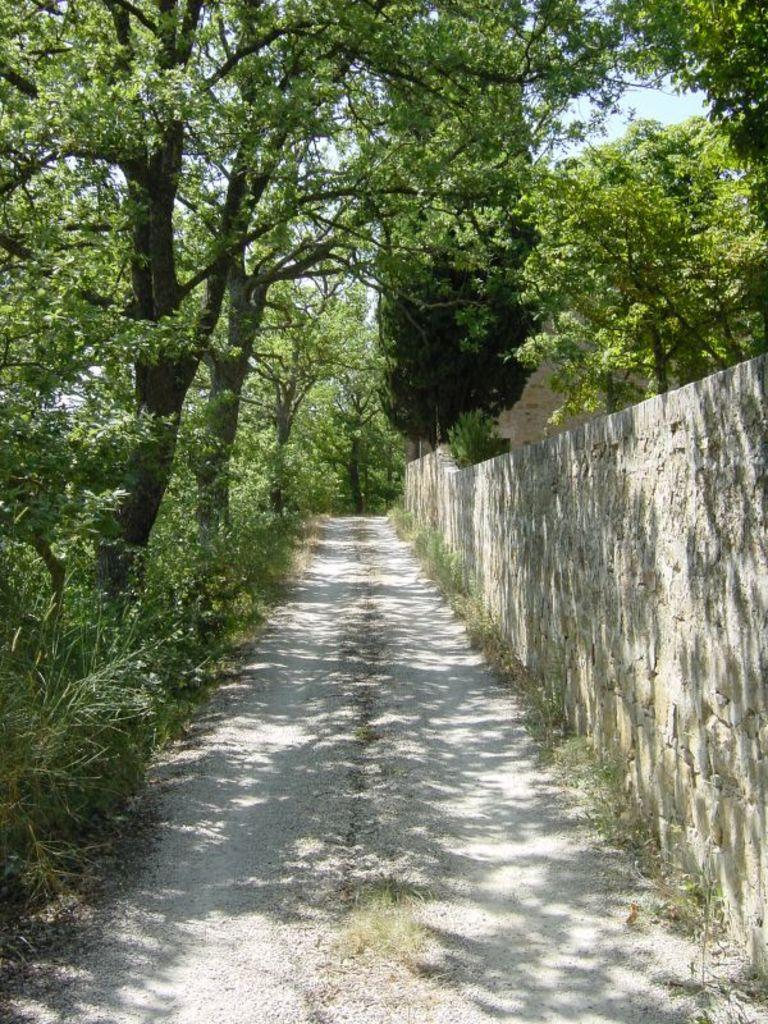What type of vegetation can be seen in the image? There are trees and plants in the image. What is located in the right corner of the image? There is a wall in the right corner of the image. Is there a clear path in the image? Yes, there is a path between the trees and the wall. Where is the hammer being used by the parent in the image? There is no hammer or parent present in the image. What is stored in the cellar in the image? There is no cellar present in the image. 